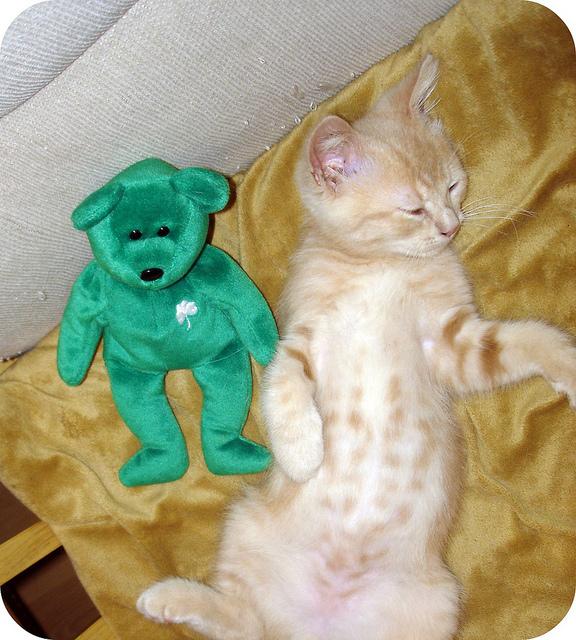What color is the stuffed animal?
Concise answer only. Green. Is this a stuffed cat?
Give a very brief answer. No. Where is the kitten?
Short answer required. Blanket. Are the stuffed animal and live animal the same color?
Write a very short answer. No. 